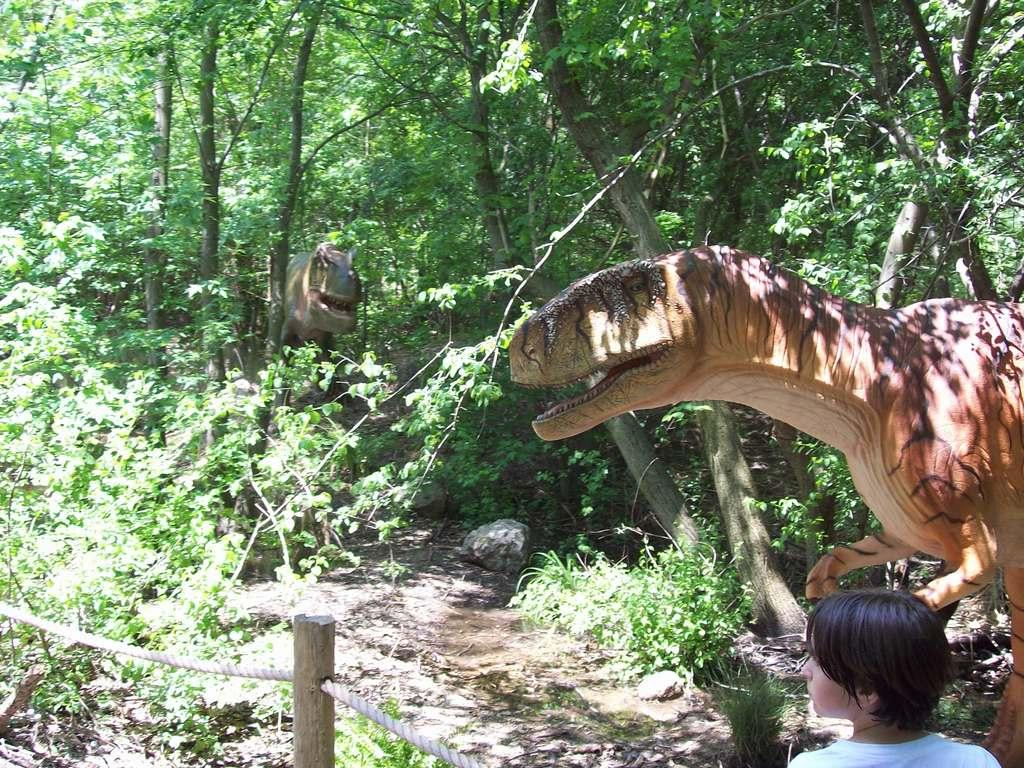What type of natural environment is depicted in the image? The image contains a forest with trees and plants. Is there a specific feature within the forest? Yes, there is a path in the forest. Are there any people present in the image? Yes, there are people standing near a rope railing. What additional objects can be seen in the image? There are two dinosaur sculptures in the image. Can you tell me how many pickles are hanging from the trees in the image? There are no pickles present in the image; it features a forest with trees and plants, a path, people near a rope railing, and two dinosaur sculptures. 